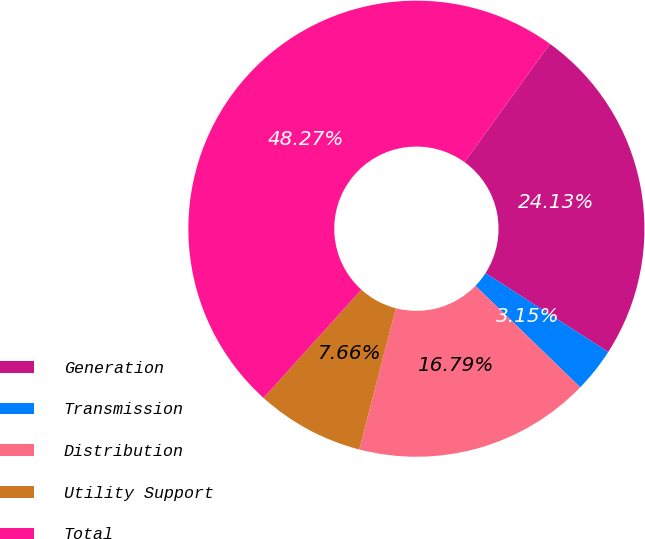Convert chart to OTSL. <chart><loc_0><loc_0><loc_500><loc_500><pie_chart><fcel>Generation<fcel>Transmission<fcel>Distribution<fcel>Utility Support<fcel>Total<nl><fcel>24.13%<fcel>3.15%<fcel>16.79%<fcel>7.66%<fcel>48.27%<nl></chart> 